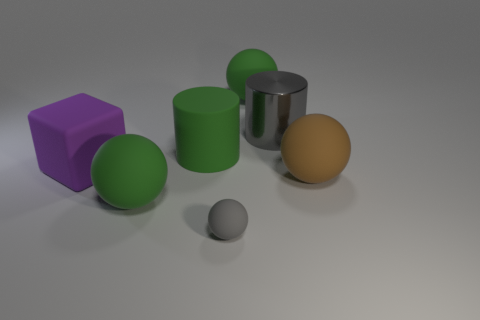Subtract all small spheres. How many spheres are left? 3 Subtract all red cylinders. How many green balls are left? 2 Subtract all gray balls. How many balls are left? 3 Add 1 tiny blue shiny spheres. How many objects exist? 8 Subtract all balls. How many objects are left? 3 Add 5 gray balls. How many gray balls are left? 6 Add 4 large brown spheres. How many large brown spheres exist? 5 Subtract 0 purple cylinders. How many objects are left? 7 Subtract all blue balls. Subtract all cyan blocks. How many balls are left? 4 Subtract all small gray rubber balls. Subtract all big brown rubber things. How many objects are left? 5 